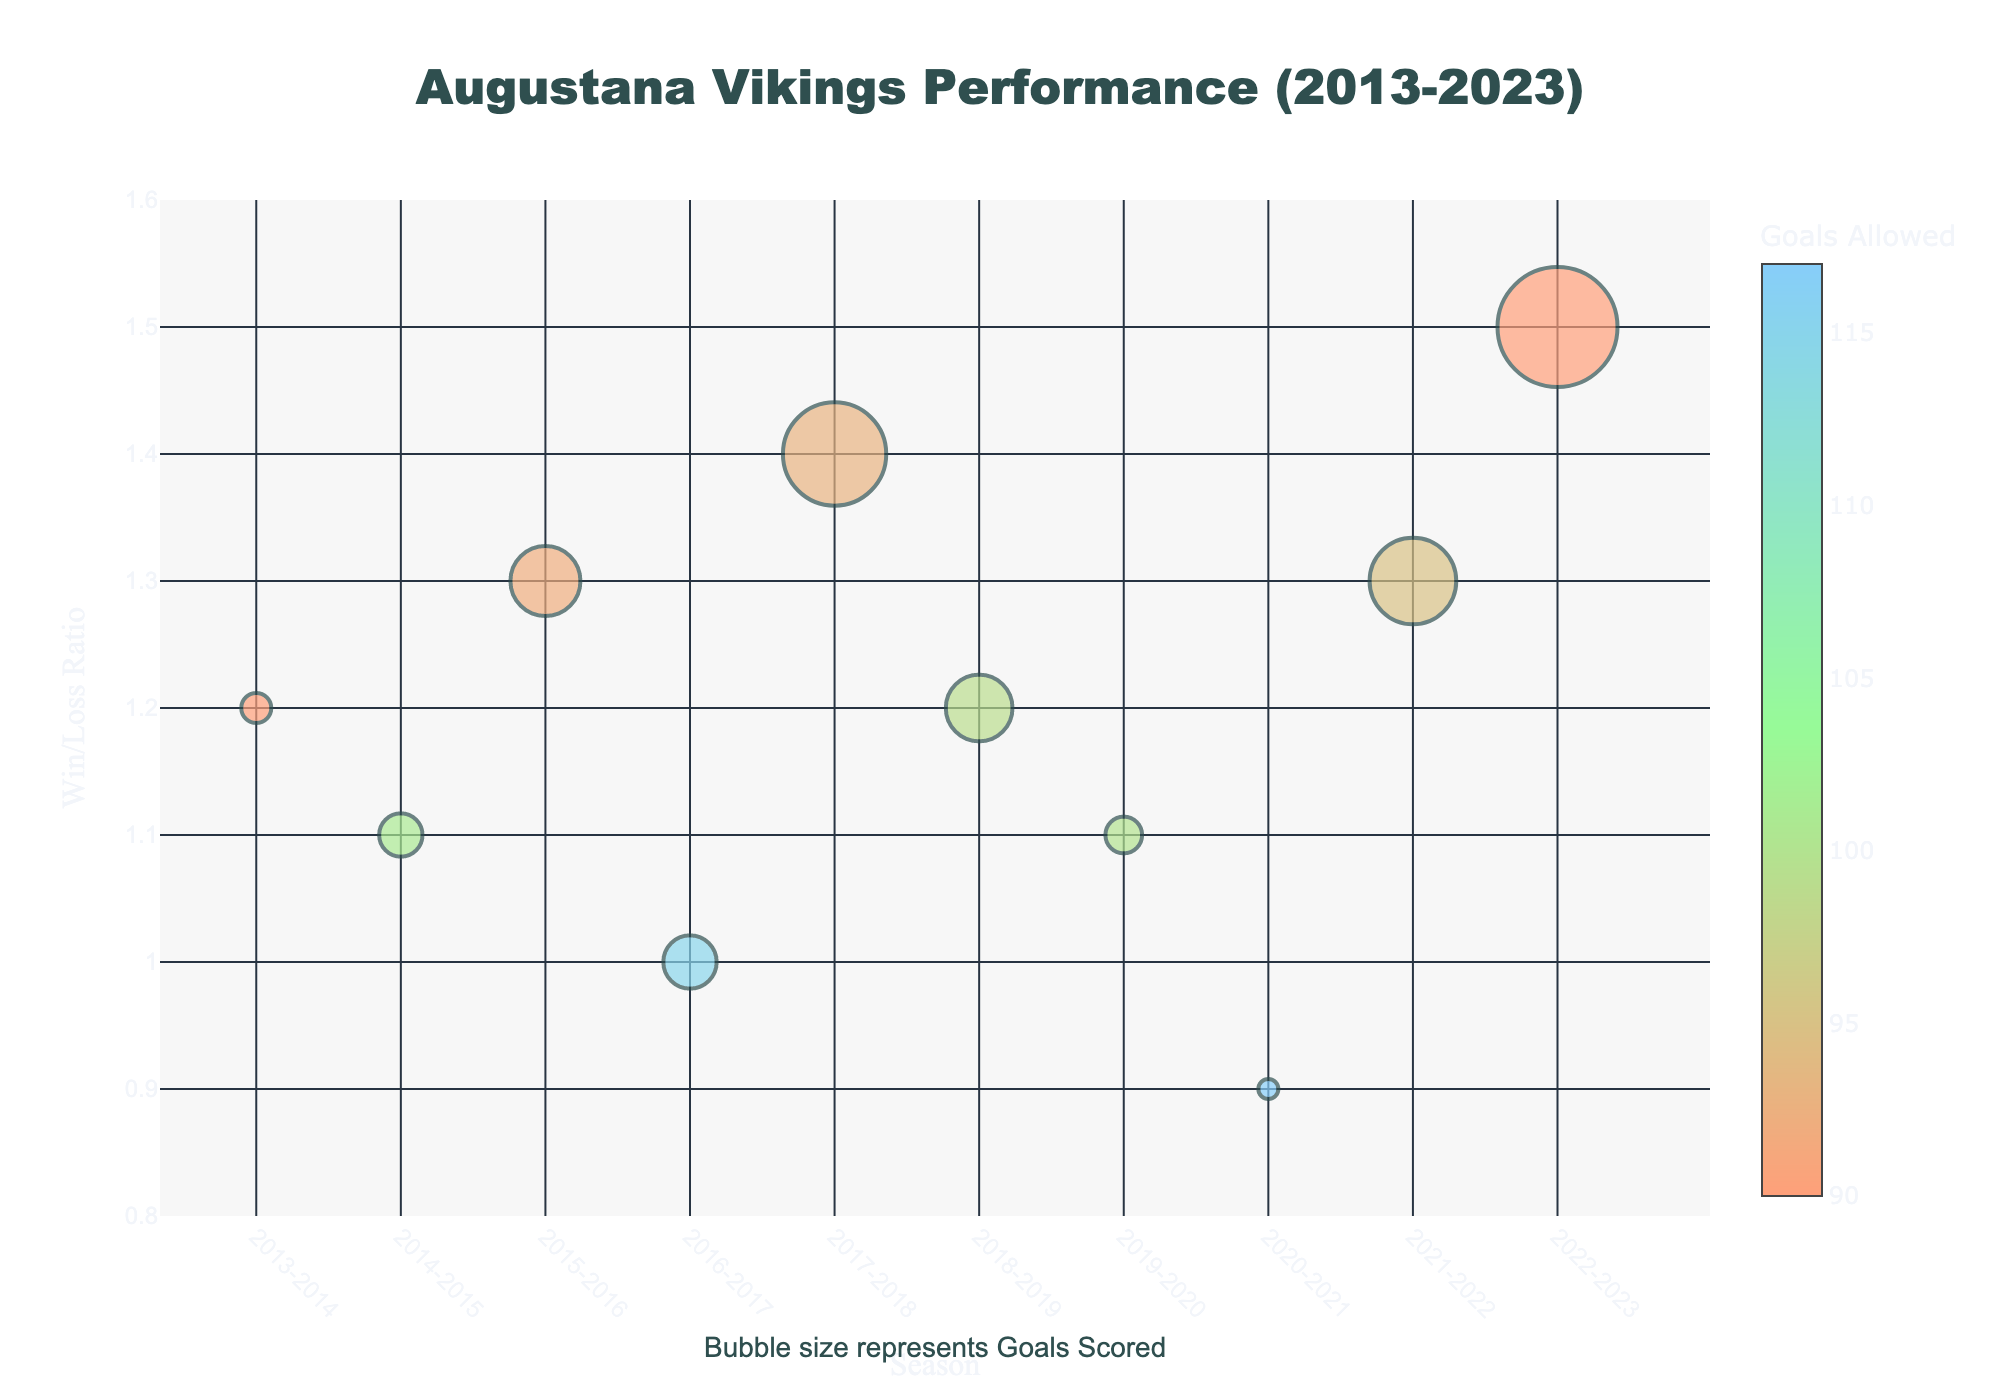How many seasons are displayed in the chart? Count the number of bubbles (one per season) on the x-axis labeled "Season."
Answer: 10 Which season has the highest win/loss ratio? Identify the highest point on the y-axis (Win/Loss Ratio) and check the x-axis label of that point.
Answer: 2022-2023 What is the bubble size representing 2022-2023 season? Compare the bubble sizes; the largest bubble corresponds to Goals Scored and is labeled 135.
Answer: 135 Which season has the lowest win/loss ratio? Identify the lowest point on the y-axis (Win/Loss Ratio) and check the x-axis label of that point.
Answer: 2020-2021 How does the bubble size relate to goals scored? Refer to the chart's annotation specifying "Bubble size represents Goals Scored." Larger bubbles indicate more goals scored.
Answer: Bubble size increases with goals scored In which season did the Augustana Vikings score 108 goals, and what was their win/loss ratio that season? Locate the bubble with the specified size (small for 108 goals) and its corresponding y-axis value while checking the hover info text.
Answer: 2013-2014, 1.2 What correlation can you observe between Goals Allowed and Win/Loss Ratio? Evaluate the colors of the bubbles (representing Goals Allowed) in relation to their vertical positions (Win/Loss Ratio). Darker colors generally appear lower on the y-axis, reflecting a negative correlation.
Answer: Generally, as Goals Allowed increases, Win/Loss Ratio decreases Which season has the maximum Goals Allowed and what was its Win/Loss Ratio? Identify the bubble with the darkest color representing Goals Allowed of 117 and find its position on the y-axis and the hover info text for detailed information.
Answer: 2020-2021, 0.9 Locate the season that had a Win/Loss Ratio of 1.4. How many goals were scored and allowed in that season? Find the bubble at y=1.4 on the chart and inspect its hover info text for details on Goals Scored and Goals Allowed.
Answer: 2017-2018, 130 goals scored, 93 goals allowed 